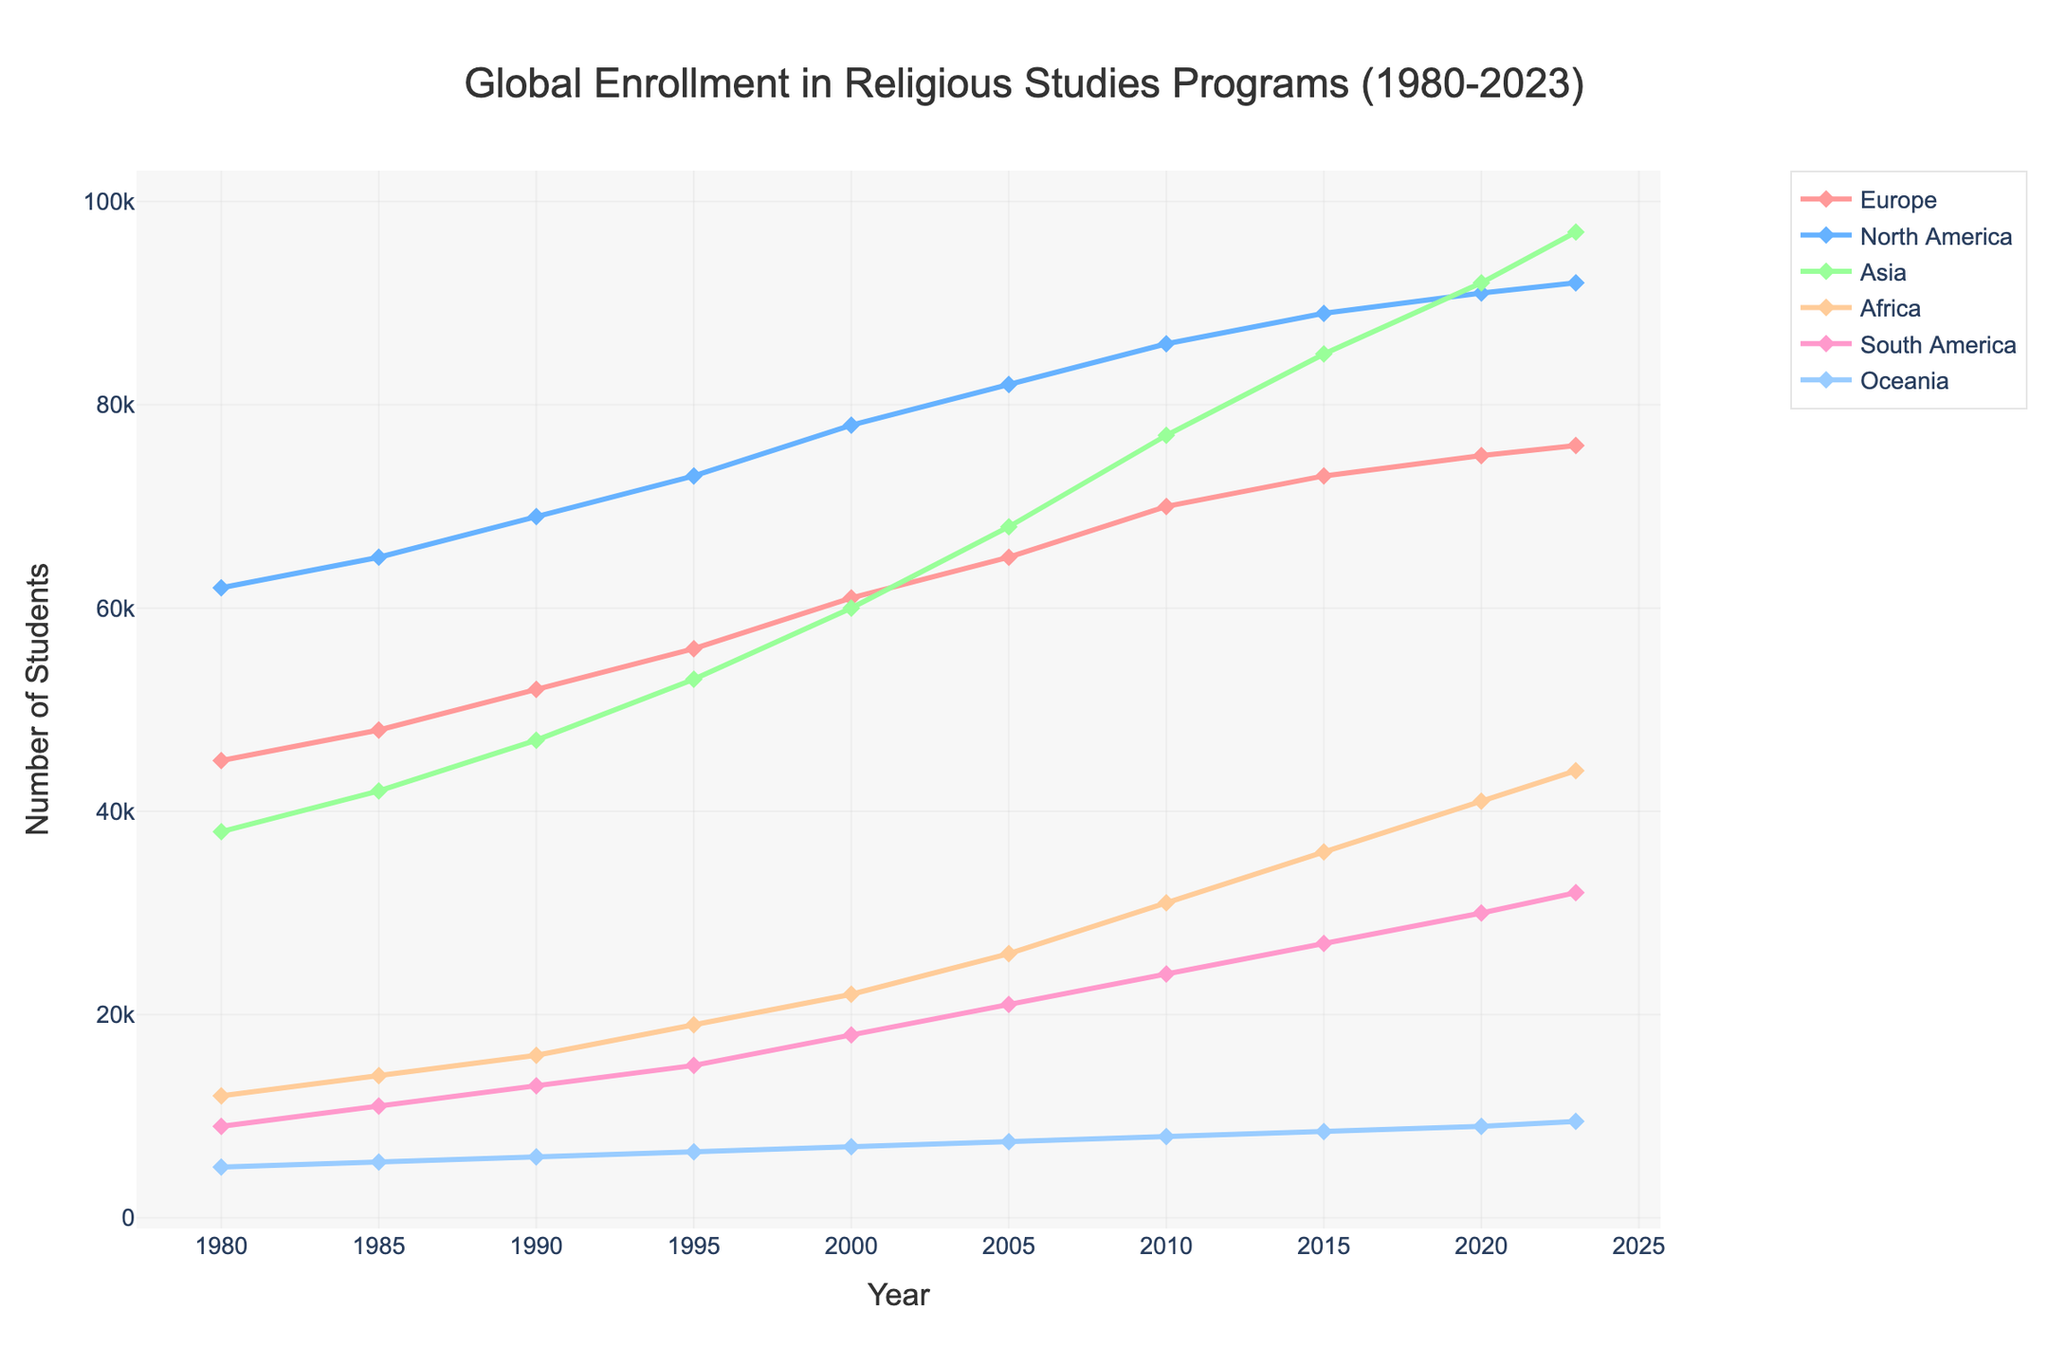Which continent had the highest number of enrollments in religious studies programs in 2023? Look at the final data points for each continent and identify which one is the highest. North America shows the highest value at 92,000 enrollments.
Answer: North America By how much did the enrollment in religious studies programs in Europe increase from 1980 to 2023? Subtract the 1980 enrollment value for Europe from the 2023 value: 76,000 (2023) - 45,000 (1980) = 31,000.
Answer: 31,000 Which continent showed the most significant increase in enrollments from 1980 to 2023? Calculate the difference in enrollments for each continent from 1980 to 2023 and compare: Europe (31,000), North America (30,000), Asia (59,000), Africa (32,000), South America (23,000), Oceania (4,500). Asia has the highest increase.
Answer: Asia Compare the enrollment trends of North America and Europe. In which years did North America's enrollments exceed Europe's by more than 20,000 students? Observe the trends and locate the years where the difference exceeds 20,000: 1980 (17,000), 1985 (17,000), 1990 (17,000), 1995 (17,000), 2000 (17,000), 2005 (17,000), 2010 (16,000), 2015 (16,000), 2020 (16,000), 2023 (16,000). North America’s enrollments exceeded Europe’s by 20,000 or more from 1980 to 2023.
Answer: None What is the percentage increase of enrollments in religious studies in Asia from 1985 to 2023? Calculate the difference and then the percentage: (97,000 - 42,000) / 42,000 * 100 = 130.95%.
Answer: 130.95% Which continental enrollment trend appears to be the most stable, with the least fluctuations over the years? Observe each line and identify the one with the least variation from year to year. Oceania shows the least fluctuation with a steady increase.
Answer: Oceania What is the average annual growth rate in enrollments for Africa between 2000 and 2023? Calculate the differences and then find the average increase per year: (44,000 - 22,000) = 22,000; 22,000 / 23 years = 956.52.
Answer: 956.52 During which decades did South America see the most significant rise in enrollments? Compare the increments for each decade: 1980s (2,000), 1990s (4,000), 2000s (3,000), 2010s (6,000). The 2010s saw the most significant increase.
Answer: 2010s How did Oceania's enrollment trend compare to that of Africa? Compare the overall patterns: Africa consistently increased more sharply, while Oceania's growth was steady but smaller.
Answer: Oceania grew steadily; Africa grew sharply What is the sum of enrollments across all continents in 2023? Add the enrollment values for all continents for 2023: 76,000 + 92,000 + 97,000 + 44,000 + 32,000 + 9,500 = 350,500.
Answer: 350,500 